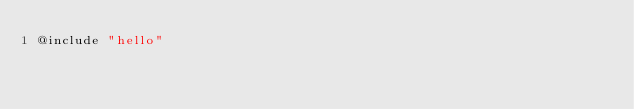<code> <loc_0><loc_0><loc_500><loc_500><_Awk_>@include "hello"
</code> 